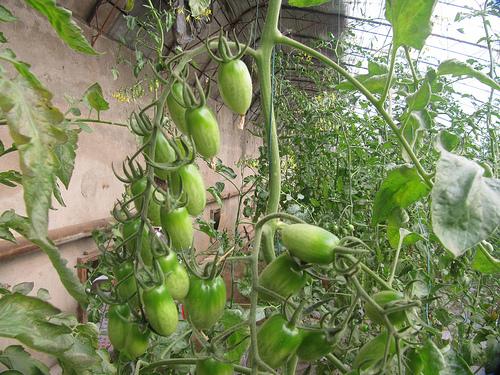<image>
Is the flower on the stem? No. The flower is not positioned on the stem. They may be near each other, but the flower is not supported by or resting on top of the stem. 